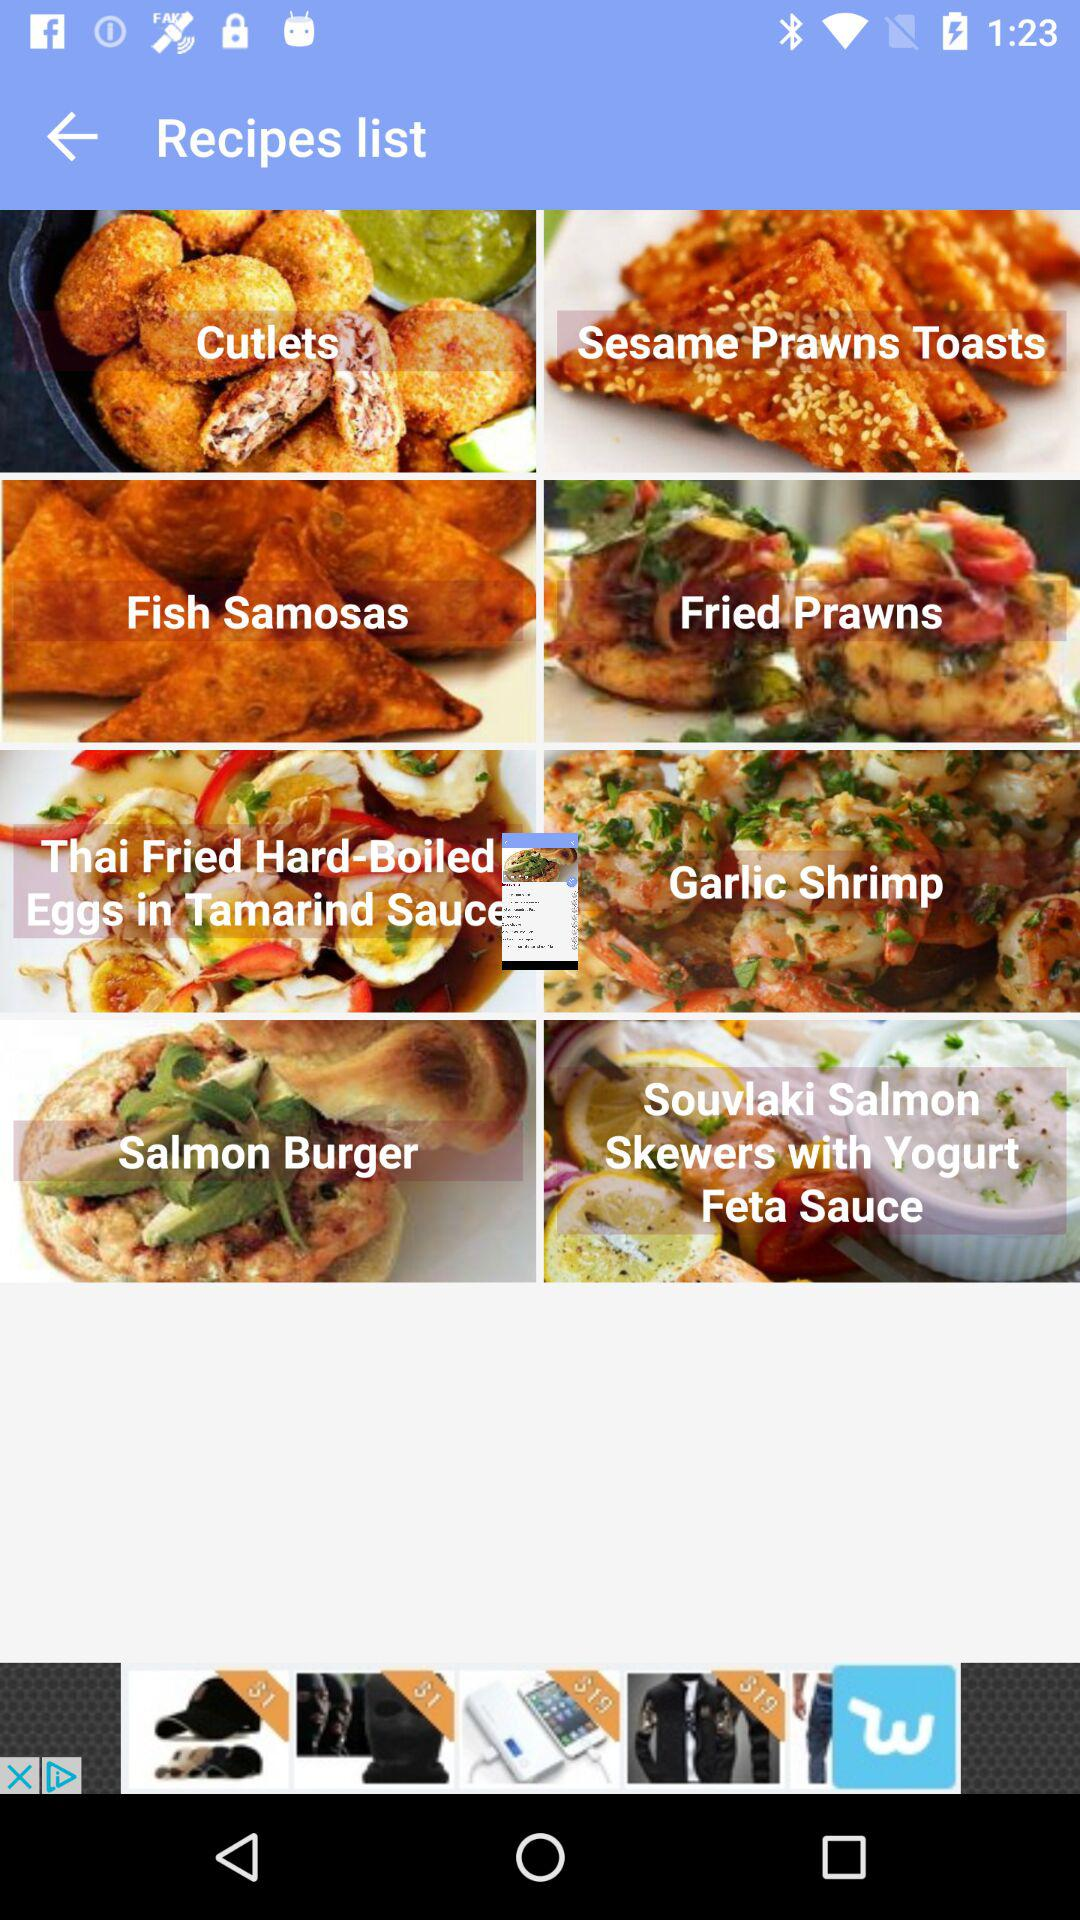How long does it take to make fish samosas?
When the provided information is insufficient, respond with <no answer>. <no answer> 